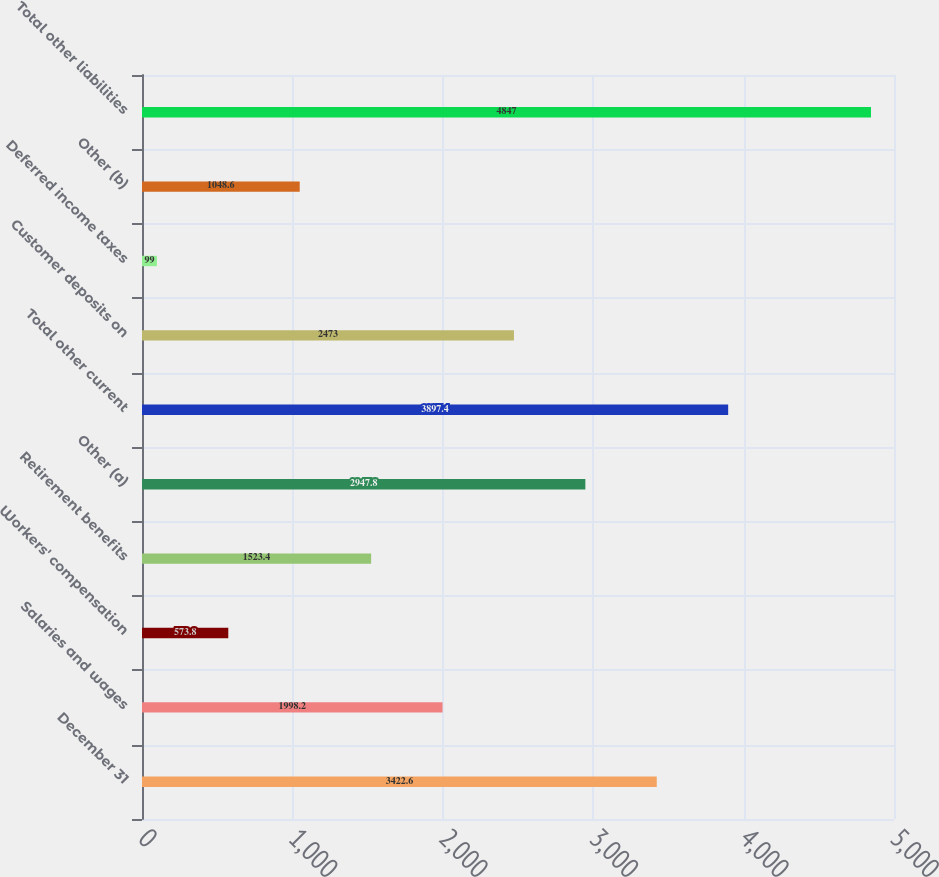<chart> <loc_0><loc_0><loc_500><loc_500><bar_chart><fcel>December 31<fcel>Salaries and wages<fcel>Workers' compensation<fcel>Retirement benefits<fcel>Other (a)<fcel>Total other current<fcel>Customer deposits on<fcel>Deferred income taxes<fcel>Other (b)<fcel>Total other liabilities<nl><fcel>3422.6<fcel>1998.2<fcel>573.8<fcel>1523.4<fcel>2947.8<fcel>3897.4<fcel>2473<fcel>99<fcel>1048.6<fcel>4847<nl></chart> 